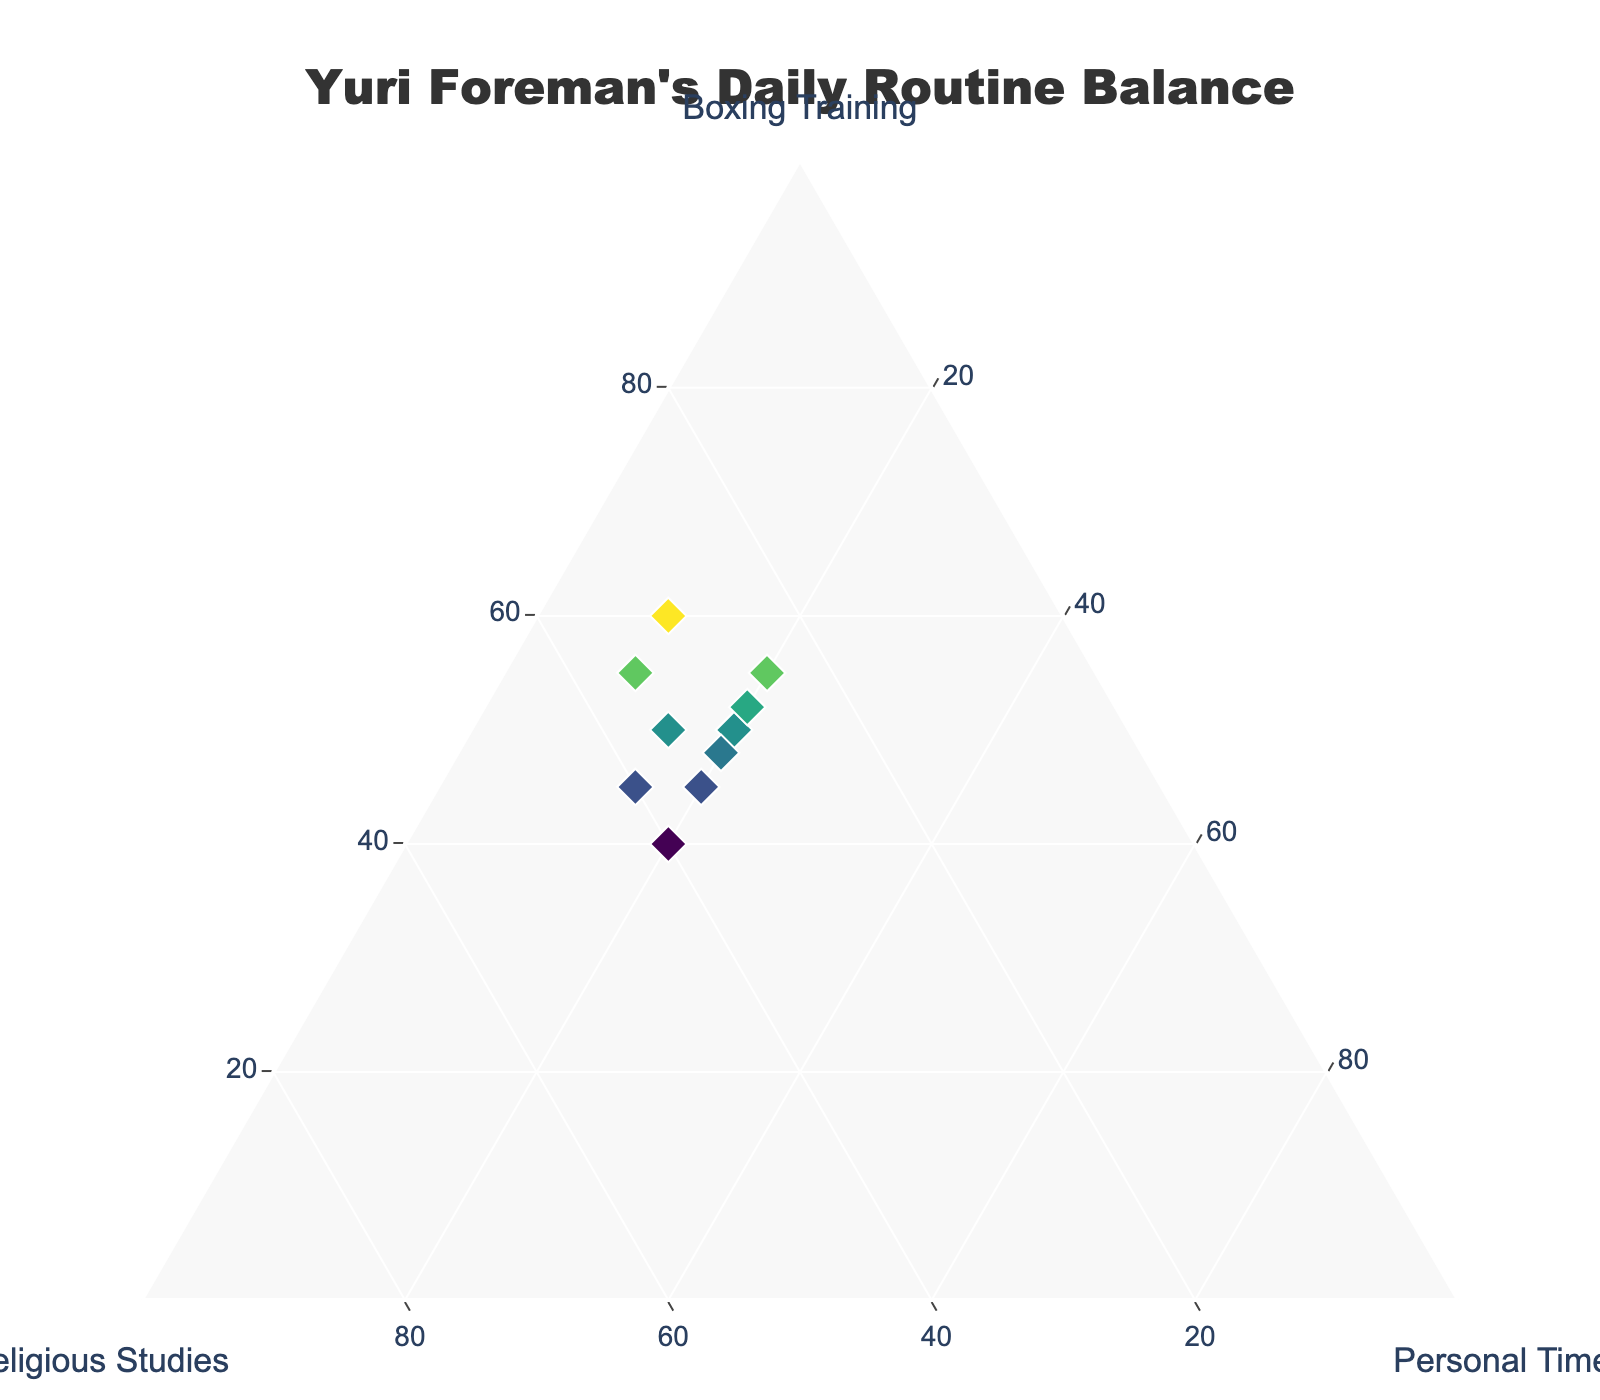How many data points are present in the figure? There are 10 rows in the provided data, so the figure has 10 data points.
Answer: 10 What colors are used for the markers in the plot? The figure uses a Viridis colorscale for the markers, showing different shades depending on the boxing training percentage.
Answer: Various shades from the Viridis colorscale What is the title of the plot? The title of the plot is "Yuri Foreman's Daily Routine Balance". It is visible at the top of the figure in the center.
Answer: Yuri Foreman's Daily Routine Balance Which axis represents Religious Studies? The b-axis represents Religious Studies in the ternary plot. This can be observed from the axis title.
Answer: b-axis What is the range of percentages used for Personal Time? The Personal Time values in the data range from 10% to 20%.
Answer: 10%-20% Which data point has the highest percentage of Boxing Training? The data point with 60% Boxing Training is the highest.
Answer: 60% How many data points have a higher percentage of Religious Studies than Boxing Training? By comparing the values of 'Religious Studies' and 'Boxing Training' for all data points, there are two points where the percentage of Religious Studies is higher (40%).
Answer: 2 What is the average percentage for Boxing Training across all data points? Calculate the average of Boxing Training percentages: (60 + 55 + 50 + 45 + 40 + 55 + 50 + 45 + 52 + 48) / 10 = 500 / 10 = 50%
Answer: 50% Which data point has the closest balance among the three activities? The data point with 40% Boxing Training, 40% Religious Studies, and 20% Personal Time is closest to balance.
Answer: 40%, 40%, 20% What is the difference between the highest and lowest percentages for Personal Time? The highest percentage for Personal Time is 20% and the lowest is 10%. The difference is 20% - 10% = 10%.
Answer: 10% 